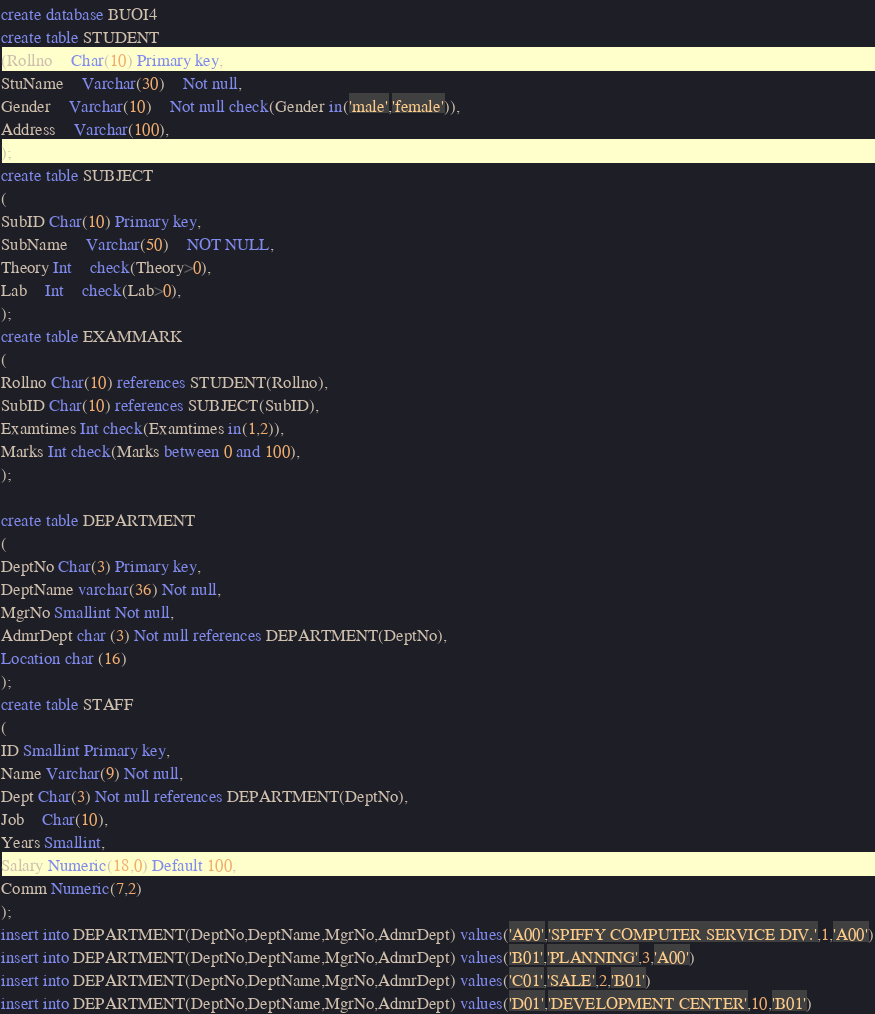<code> <loc_0><loc_0><loc_500><loc_500><_SQL_>create database BUOI4
create table STUDENT
(Rollno	Char(10) Primary key,
StuName	Varchar(30)	Not null,
Gender	Varchar(10)	Not null check(Gender in('male','female')),
Address	Varchar(100),	
);
create table SUBJECT
(
SubID Char(10) Primary key,
SubName	Varchar(50)	NOT NULL,
Theory Int	check(Theory>0),
Lab	Int	check(Lab>0),
);
create table EXAMMARK
(
Rollno Char(10) references STUDENT(Rollno),
SubID Char(10) references SUBJECT(SubID),
Examtimes Int check(Examtimes in(1,2)),
Marks Int check(Marks between 0 and 100),
);

create table DEPARTMENT
(
DeptNo Char(3) Primary key,
DeptName varchar(36) Not null,
MgrNo Smallint Not null,
AdmrDept char (3) Not null references DEPARTMENT(DeptNo),
Location char (16)
);
create table STAFF
(
ID Smallint Primary key,
Name Varchar(9) Not null,
Dept Char(3) Not null references DEPARTMENT(DeptNo),
Job	Char(10),	
Years Smallint,	
Salary Numeric(18,0) Default 100,
Comm Numeric(7,2)	
);
insert into DEPARTMENT(DeptNo,DeptName,MgrNo,AdmrDept) values('A00','SPIFFY COMPUTER SERVICE DIV.',1,'A00')
insert into DEPARTMENT(DeptNo,DeptName,MgrNo,AdmrDept) values('B01','PLANNING',3,'A00')
insert into DEPARTMENT(DeptNo,DeptName,MgrNo,AdmrDept) values('C01','SALE',2,'B01')
insert into DEPARTMENT(DeptNo,DeptName,MgrNo,AdmrDept) values('D01','DEVELOPMENT CENTER',10,'B01')</code> 